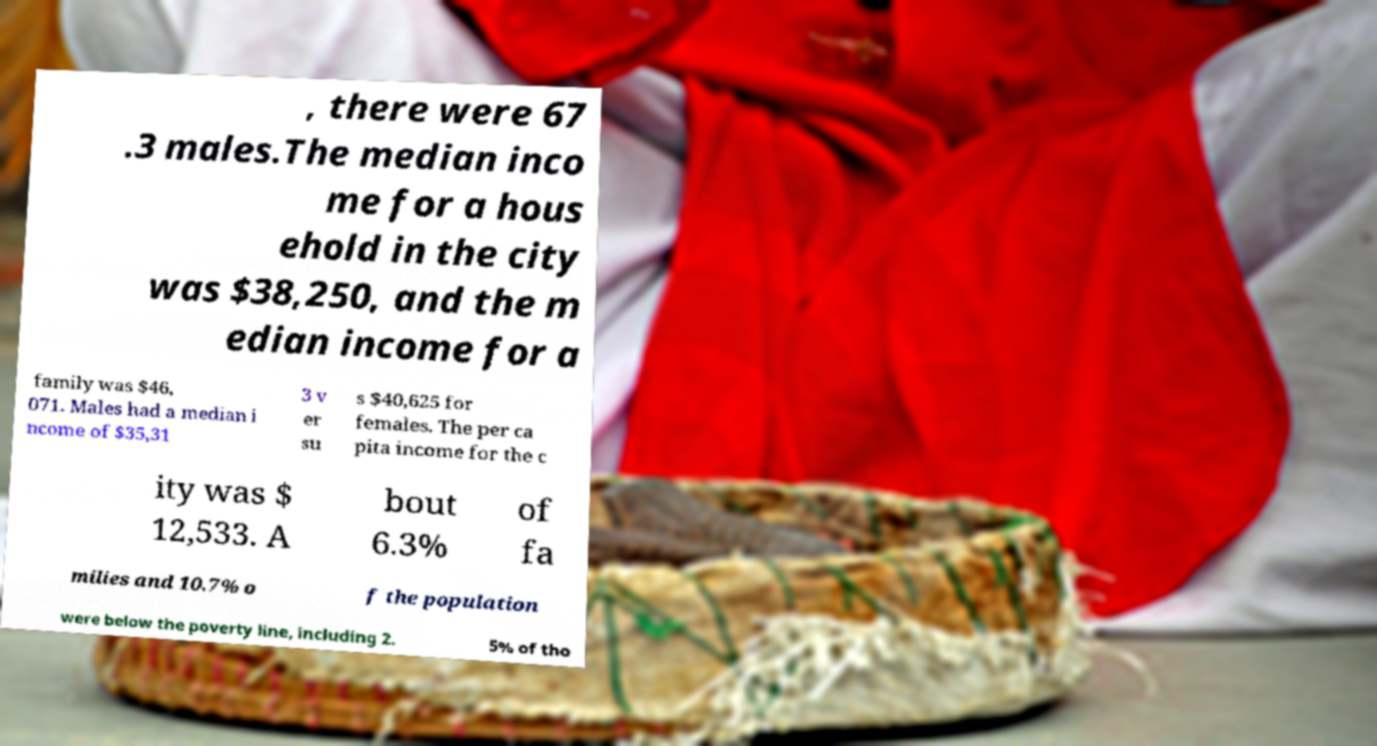There's text embedded in this image that I need extracted. Can you transcribe it verbatim? , there were 67 .3 males.The median inco me for a hous ehold in the city was $38,250, and the m edian income for a family was $46, 071. Males had a median i ncome of $35,31 3 v er su s $40,625 for females. The per ca pita income for the c ity was $ 12,533. A bout 6.3% of fa milies and 10.7% o f the population were below the poverty line, including 2. 5% of tho 